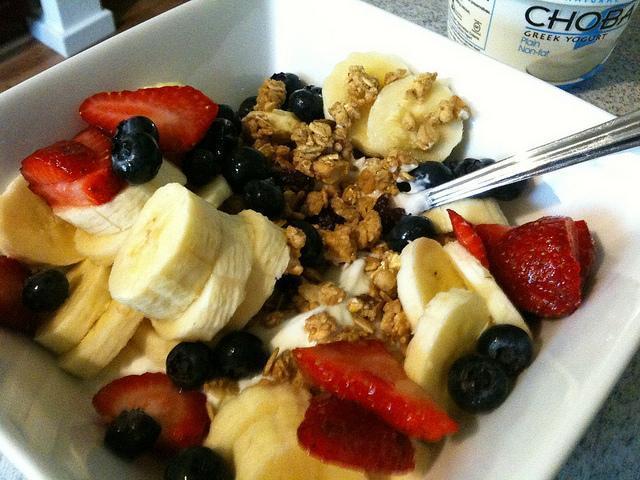How many bananas are there?
Give a very brief answer. 10. 